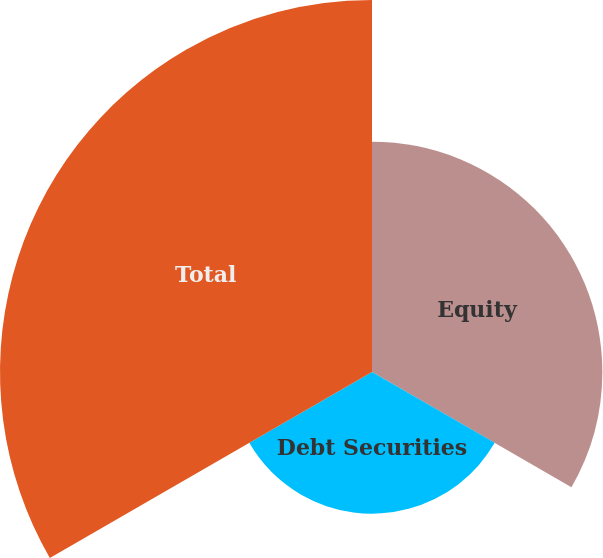<chart> <loc_0><loc_0><loc_500><loc_500><pie_chart><fcel>Equity<fcel>Debt Securities<fcel>Total<nl><fcel>30.96%<fcel>19.04%<fcel>50.0%<nl></chart> 